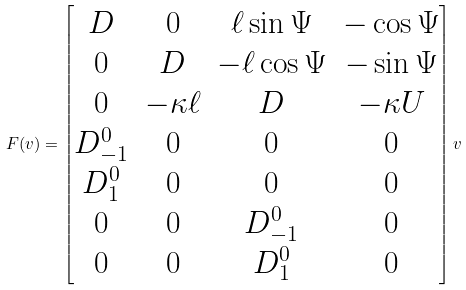<formula> <loc_0><loc_0><loc_500><loc_500>F ( v ) = \begin{bmatrix} D & 0 & \ell \sin \Psi & - \cos \Psi \\ 0 & D & - \ell \cos \Psi & - \sin \Psi \\ 0 & - \kappa \ell & D & - \kappa U \\ D ^ { 0 } _ { - 1 } & 0 & 0 & 0 \\ D ^ { 0 } _ { 1 } & 0 & 0 & 0 \\ 0 & 0 & D ^ { 0 } _ { - 1 } & 0 \\ 0 & 0 & D ^ { 0 } _ { 1 } & 0 \end{bmatrix} v</formula> 